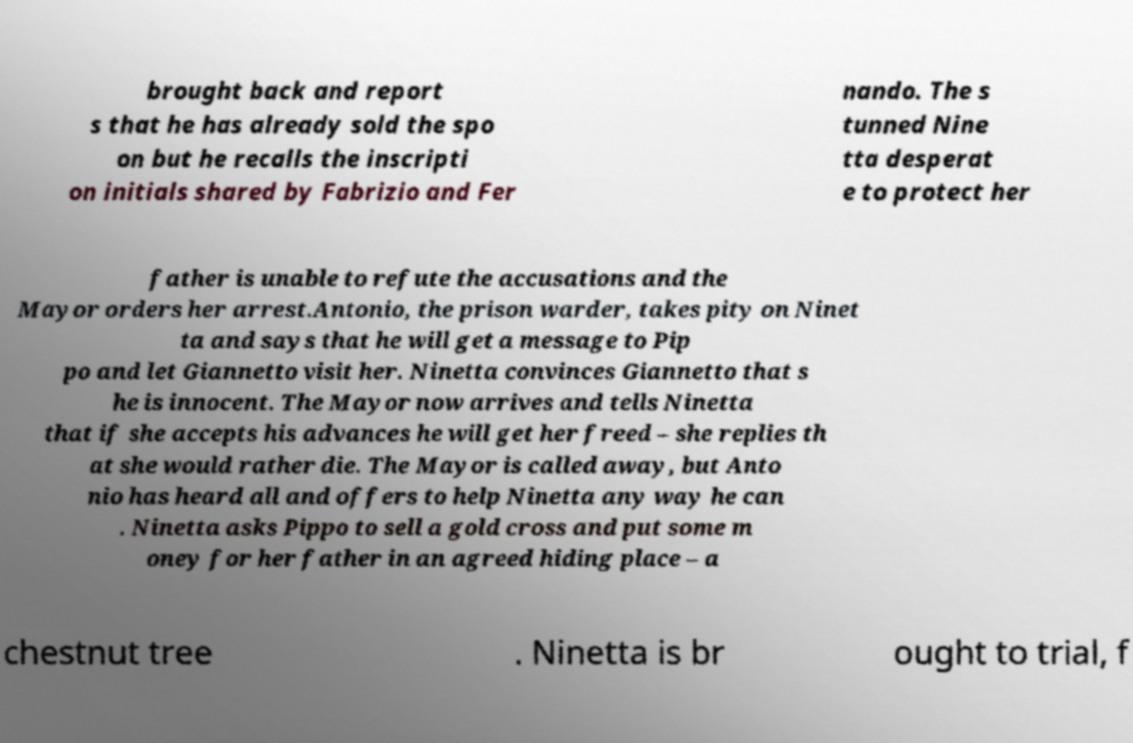Please read and relay the text visible in this image. What does it say? brought back and report s that he has already sold the spo on but he recalls the inscripti on initials shared by Fabrizio and Fer nando. The s tunned Nine tta desperat e to protect her father is unable to refute the accusations and the Mayor orders her arrest.Antonio, the prison warder, takes pity on Ninet ta and says that he will get a message to Pip po and let Giannetto visit her. Ninetta convinces Giannetto that s he is innocent. The Mayor now arrives and tells Ninetta that if she accepts his advances he will get her freed – she replies th at she would rather die. The Mayor is called away, but Anto nio has heard all and offers to help Ninetta any way he can . Ninetta asks Pippo to sell a gold cross and put some m oney for her father in an agreed hiding place – a chestnut tree . Ninetta is br ought to trial, f 